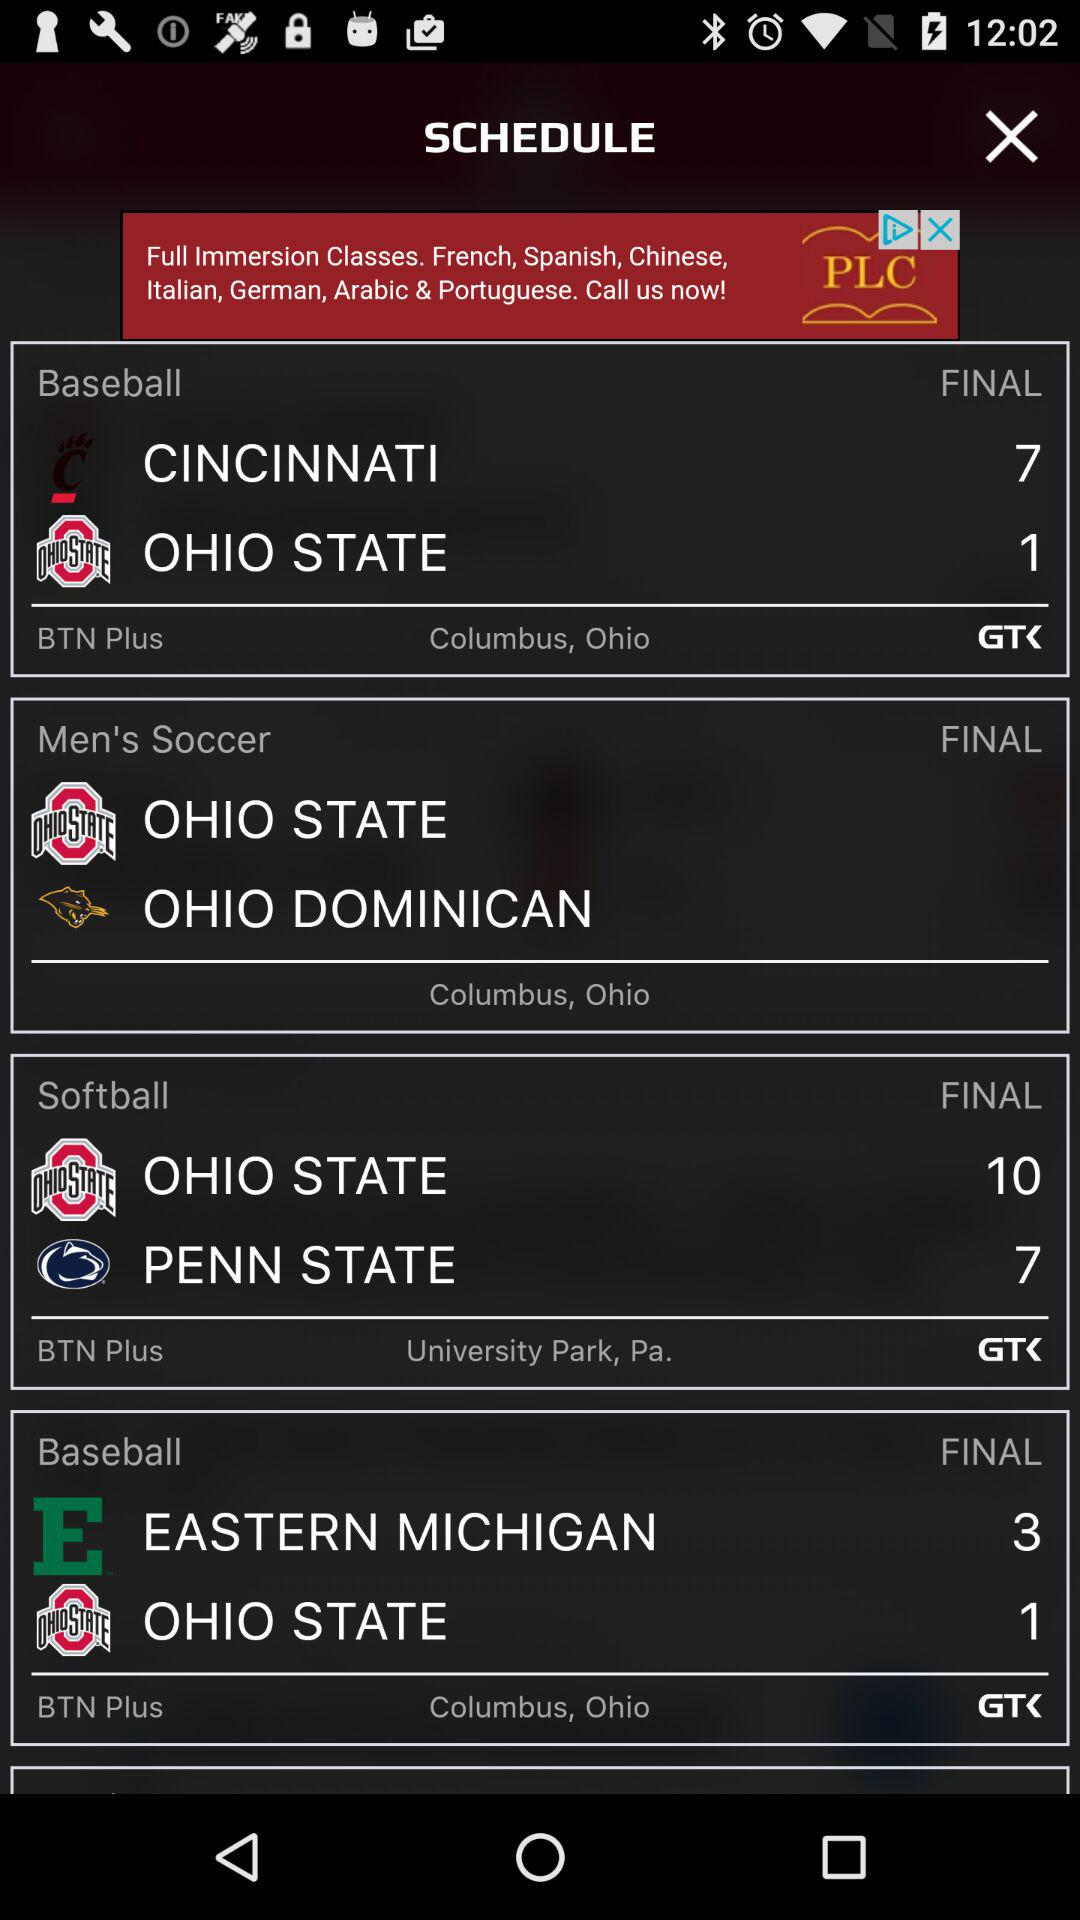What is the venue for the baseball final match? The venue for the baseball final match is Columbus, Ohio. 